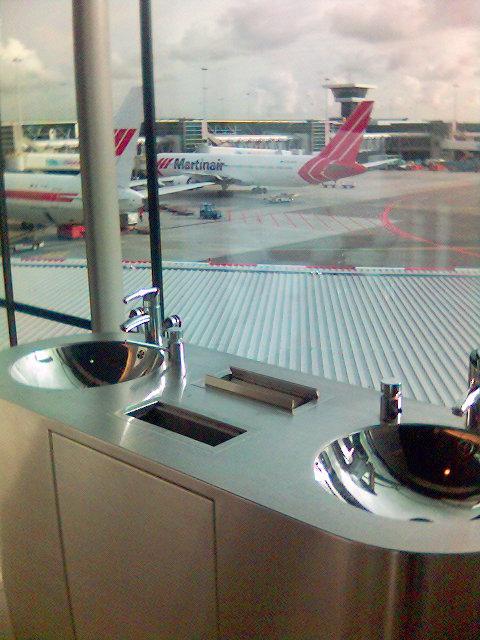Which room is this taken in?
Concise answer only. Bathroom. What color is the second plane?
Be succinct. White. Is this an airport?
Answer briefly. Yes. 